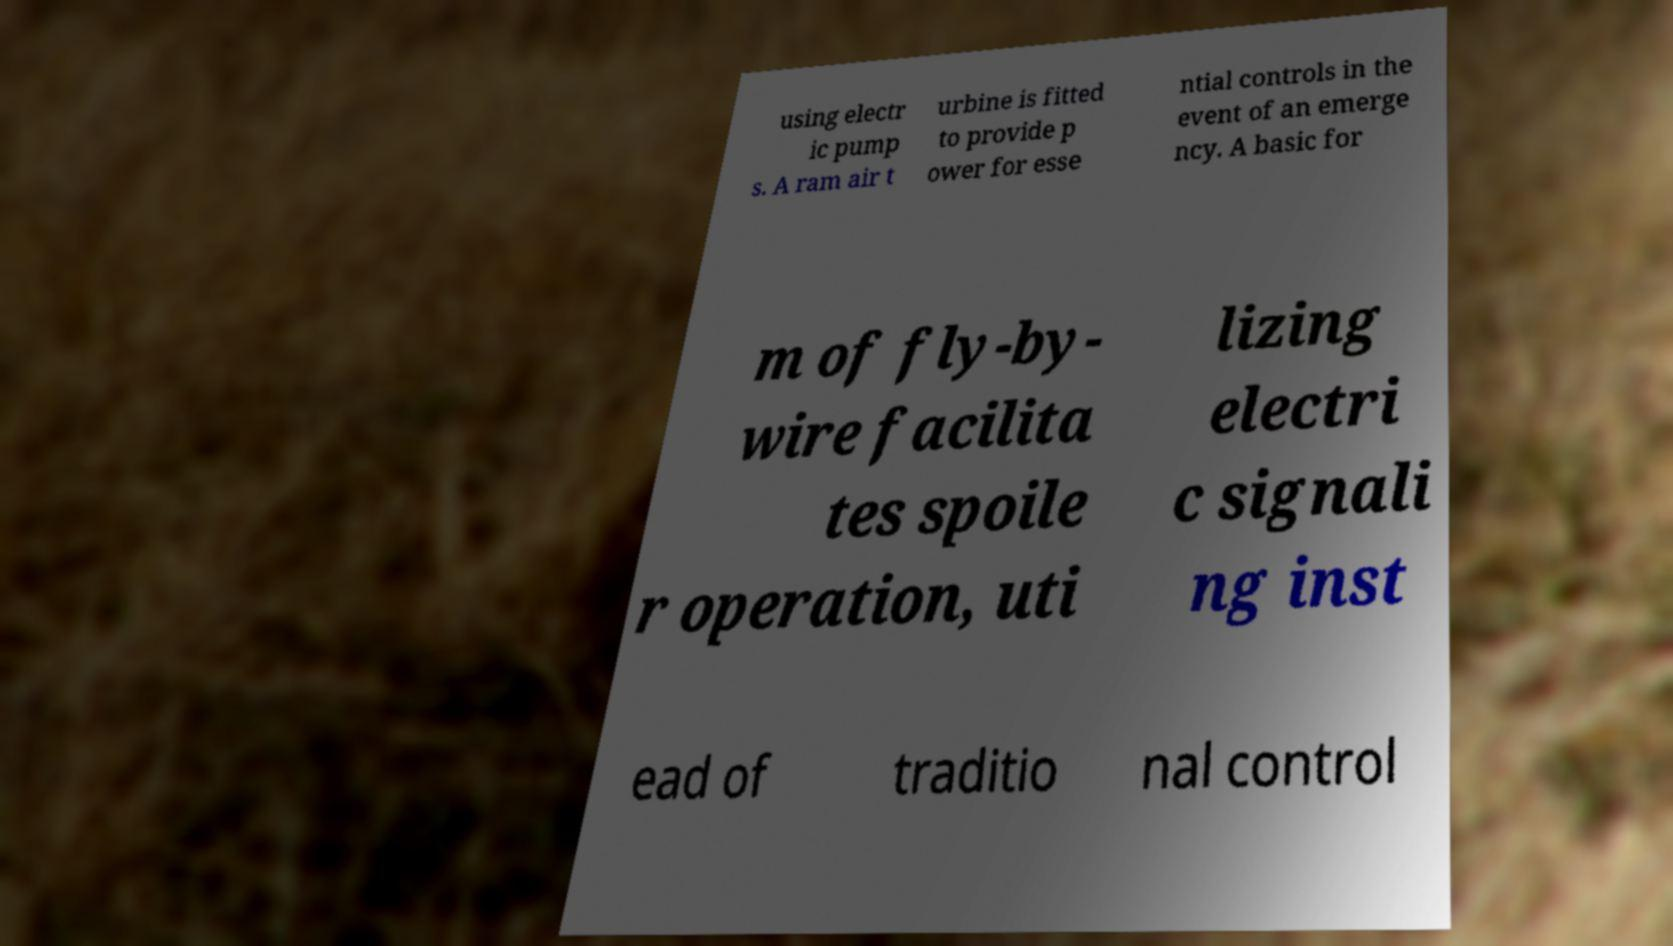There's text embedded in this image that I need extracted. Can you transcribe it verbatim? using electr ic pump s. A ram air t urbine is fitted to provide p ower for esse ntial controls in the event of an emerge ncy. A basic for m of fly-by- wire facilita tes spoile r operation, uti lizing electri c signali ng inst ead of traditio nal control 